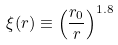<formula> <loc_0><loc_0><loc_500><loc_500>\xi ( r ) \equiv \left ( \frac { r _ { 0 } } { r } \right ) ^ { 1 . 8 }</formula> 